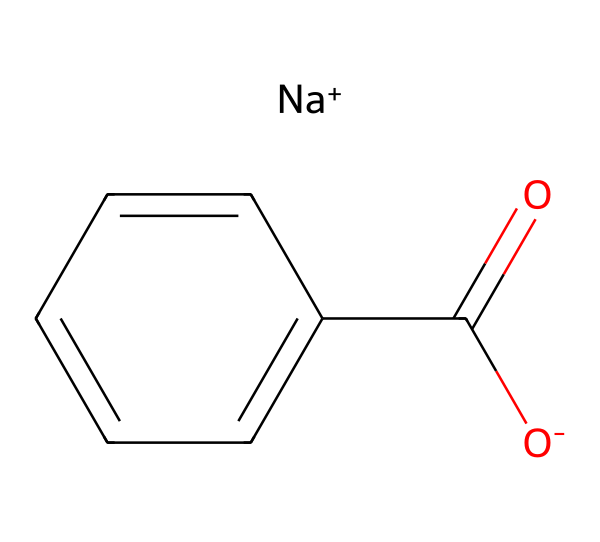What is the molecular formula of sodium benzoate? The SMILES representation indicates that sodium benzoate consists of one sodium atom (Na), one carbon atom (C), one oxygen atom (O), and six carbons from the benzene ring (c1ccccc1), leading to a total of seven carbon atoms, one oxygen, and one sodium in the formula. Thus, the molecular formula is C7H5O2Na.
Answer: C7H5O2Na How many carbon atoms are present in sodium benzoate? By analyzing the structure from the SMILES, there are six carbons in the benzene ring (c1ccccc1) and one carbon in the carboxylate group (C(=O)), totaling seven carbon atoms.
Answer: 7 What type of chemical bond connects sodium to benzoate? In the structure, sodium is ionically bonded to the carboxylate anion (O-) part of benzoate, which is evident from the presence of [Na+] and [O-]. This indicates an ionic bond due to the transfer of electrons between the sodium ion and the negatively charged carboxylate.
Answer: Ionic bond What functional group is present in sodium benzoate? The presence of the carboxylate group (C(=O)O-) in the structure indicates that sodium benzoate contains a carboxylate functional group, which is characteristic of salts derived from carboxylic acids.
Answer: Carboxylate What is the charge of the benzoate ion in sodium benzoate? The SMILES notation shows [O-], indicating a negative charge, and since the molecule is neutral overall due to the presence of [Na+], the benzoate ion (C7H5O2-) carries a single negative charge.
Answer: Negative charge 